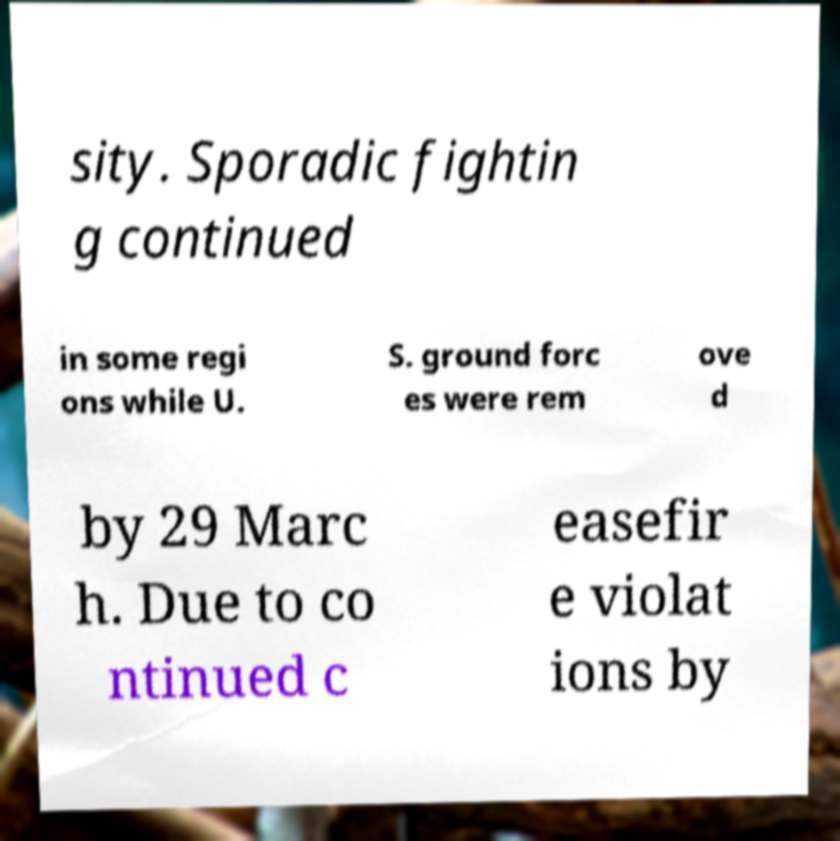Could you assist in decoding the text presented in this image and type it out clearly? sity. Sporadic fightin g continued in some regi ons while U. S. ground forc es were rem ove d by 29 Marc h. Due to co ntinued c easefir e violat ions by 